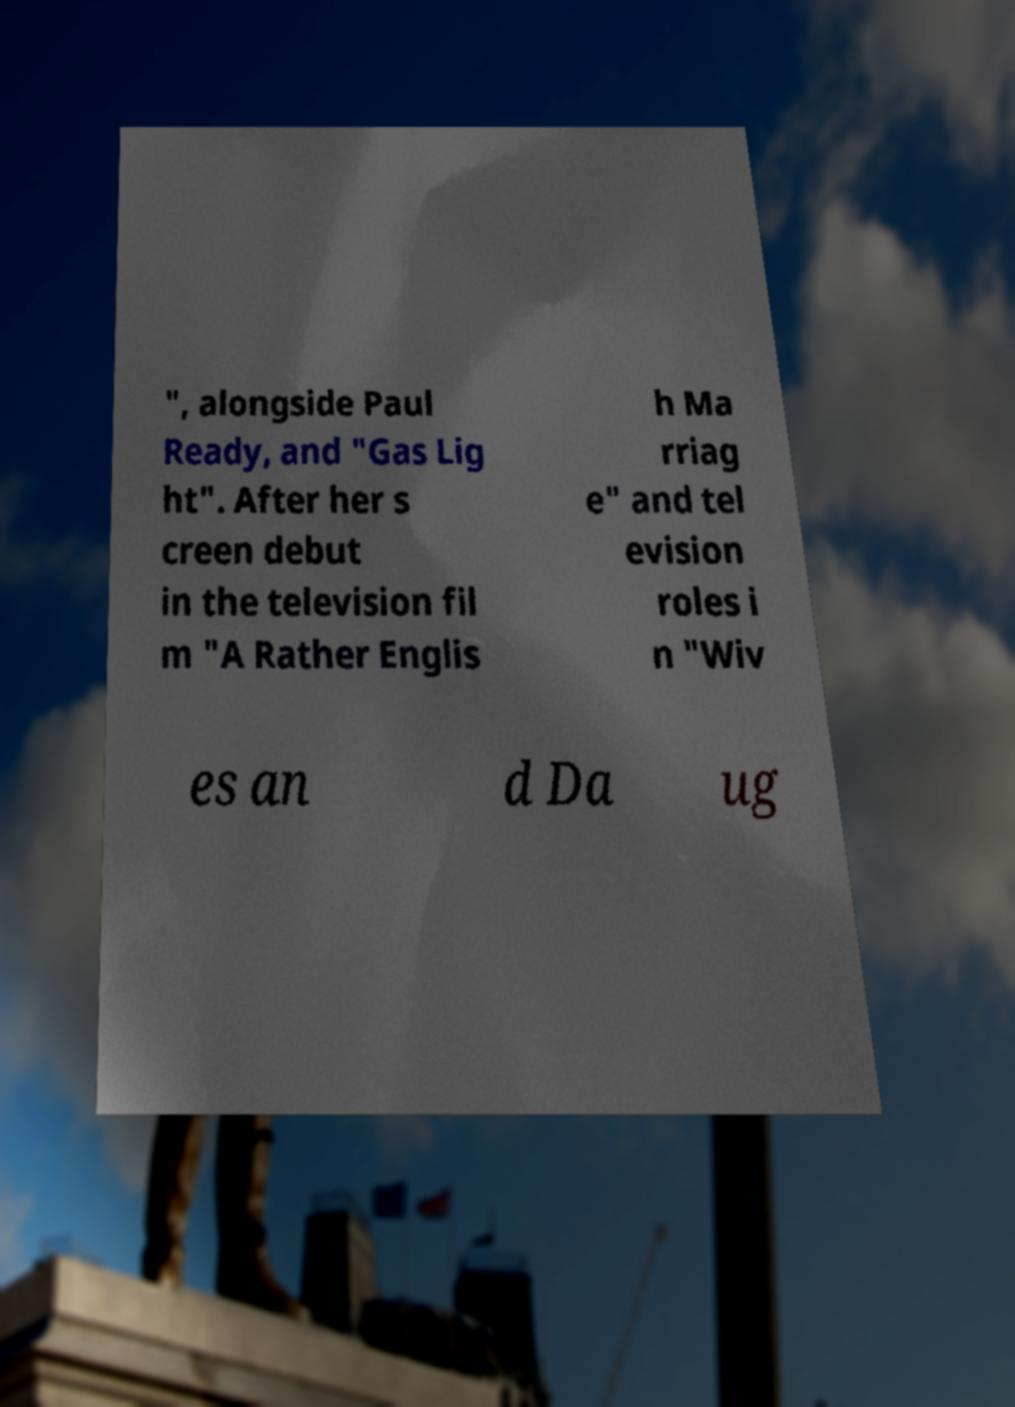Please identify and transcribe the text found in this image. ", alongside Paul Ready, and "Gas Lig ht". After her s creen debut in the television fil m "A Rather Englis h Ma rriag e" and tel evision roles i n "Wiv es an d Da ug 